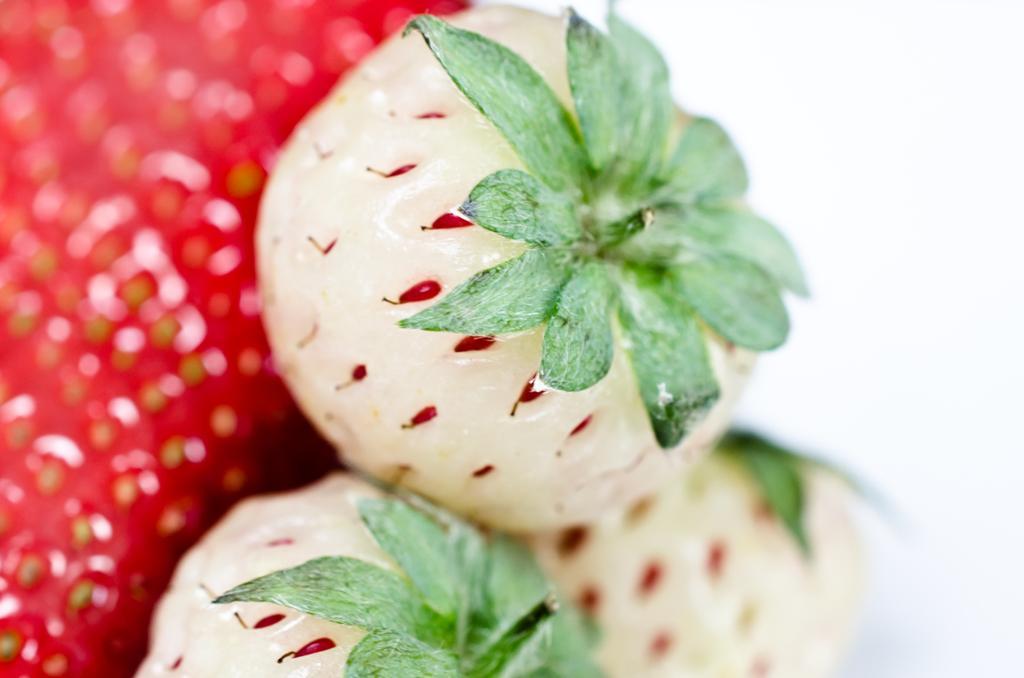Describe this image in one or two sentences. In this image we can see white strawberries and on the left side the image is blur but we can see strawberries and in the background the image is white in color. 